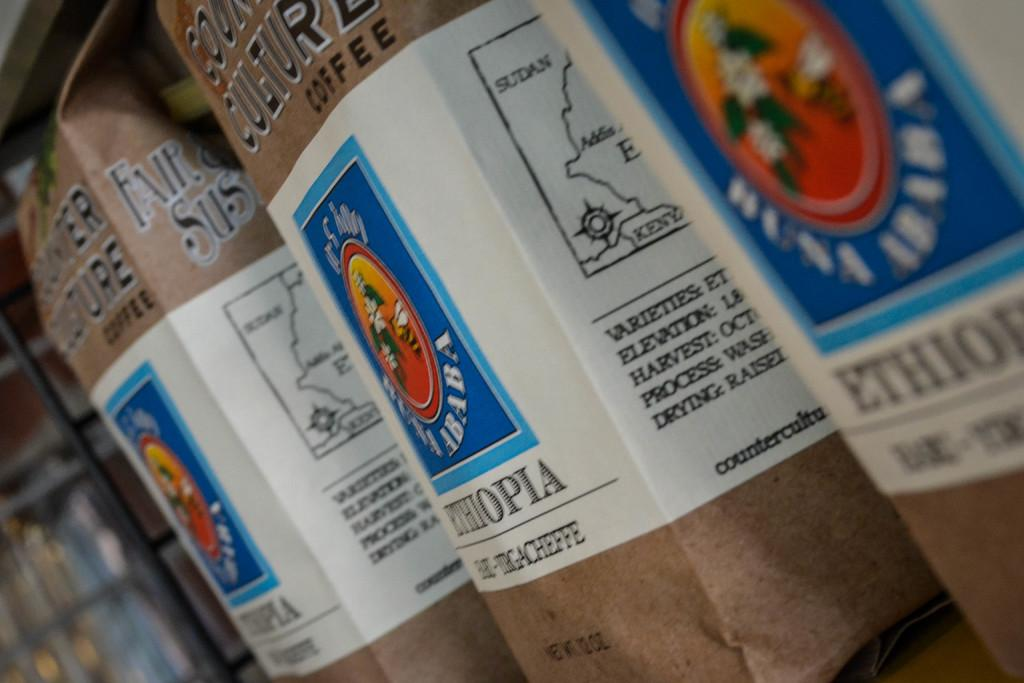<image>
Relay a brief, clear account of the picture shown. 3 bags of coffee imported from ethiopia that is brown and white 